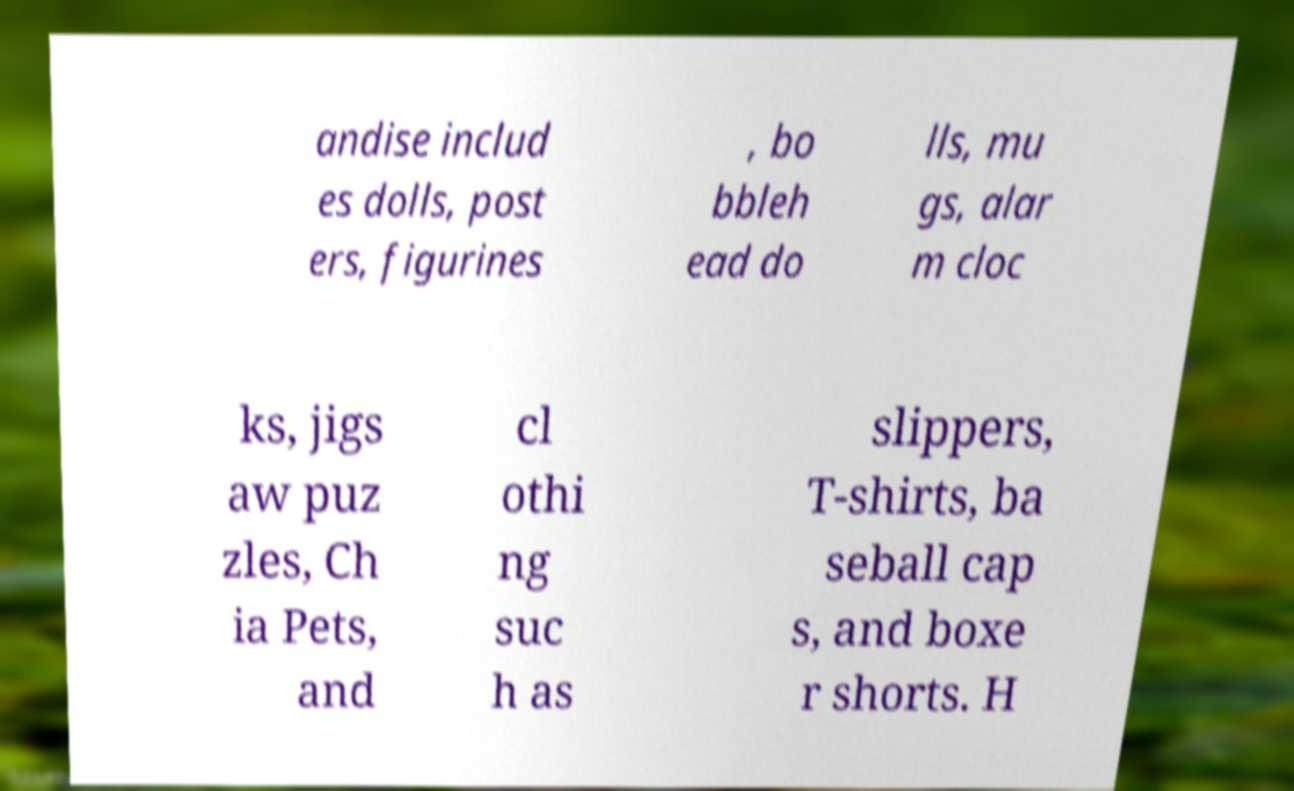I need the written content from this picture converted into text. Can you do that? andise includ es dolls, post ers, figurines , bo bbleh ead do lls, mu gs, alar m cloc ks, jigs aw puz zles, Ch ia Pets, and cl othi ng suc h as slippers, T-shirts, ba seball cap s, and boxe r shorts. H 